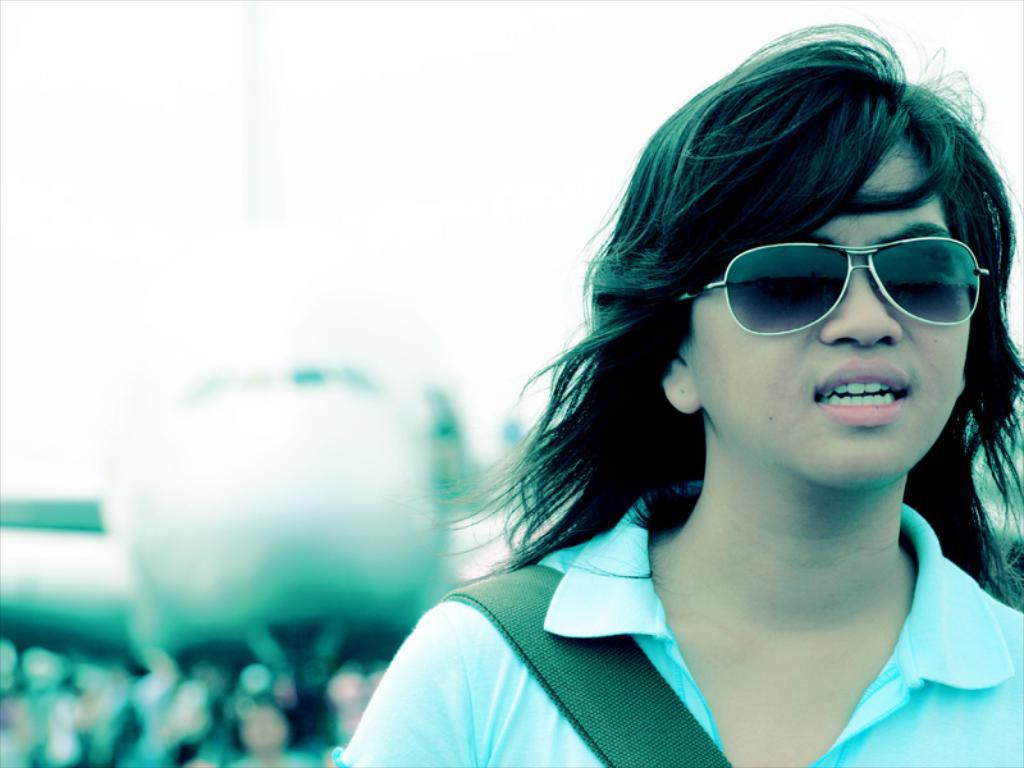Who is the main subject in the image? There is a woman in the image. What is the woman wearing on her face? The woman is wearing spectacles. What can be seen at the top of the image? The sky is visible at the top of the image. What might be happening in the bottom left of the image? There might be a flight or a crowd in the bottom left of the image. What type of drain is visible in the image? There is no drain present in the image. Can you see any berries in the image? There are no berries visible in the image. 